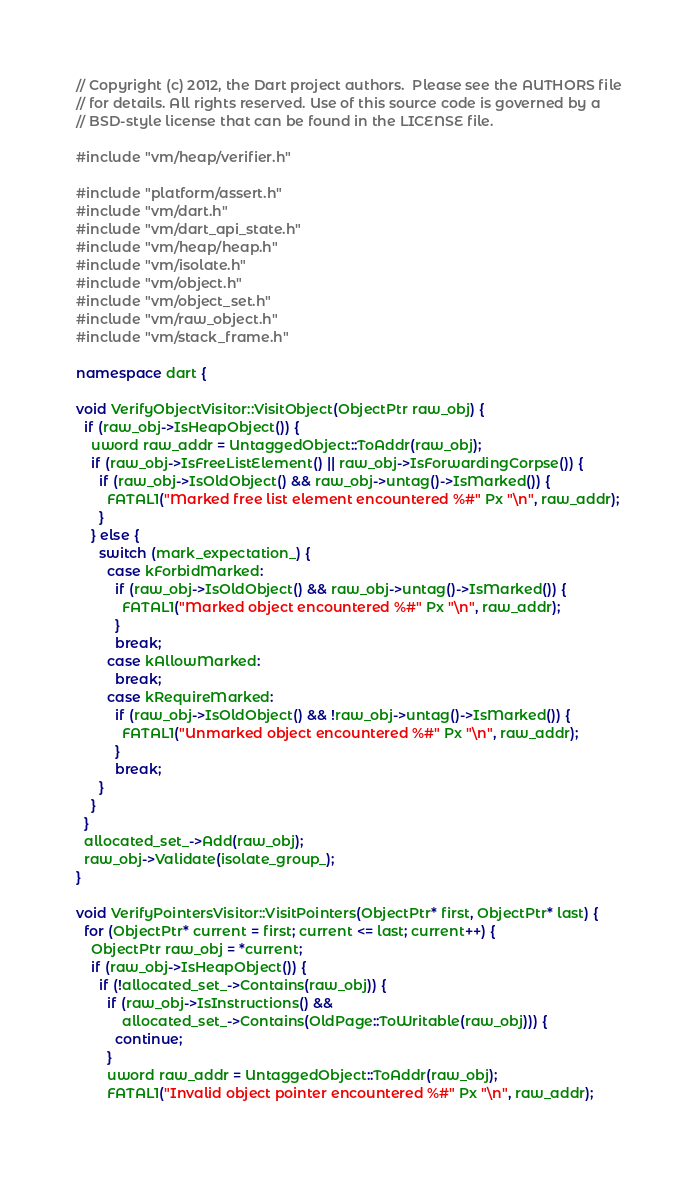Convert code to text. <code><loc_0><loc_0><loc_500><loc_500><_C++_>// Copyright (c) 2012, the Dart project authors.  Please see the AUTHORS file
// for details. All rights reserved. Use of this source code is governed by a
// BSD-style license that can be found in the LICENSE file.

#include "vm/heap/verifier.h"

#include "platform/assert.h"
#include "vm/dart.h"
#include "vm/dart_api_state.h"
#include "vm/heap/heap.h"
#include "vm/isolate.h"
#include "vm/object.h"
#include "vm/object_set.h"
#include "vm/raw_object.h"
#include "vm/stack_frame.h"

namespace dart {

void VerifyObjectVisitor::VisitObject(ObjectPtr raw_obj) {
  if (raw_obj->IsHeapObject()) {
    uword raw_addr = UntaggedObject::ToAddr(raw_obj);
    if (raw_obj->IsFreeListElement() || raw_obj->IsForwardingCorpse()) {
      if (raw_obj->IsOldObject() && raw_obj->untag()->IsMarked()) {
        FATAL1("Marked free list element encountered %#" Px "\n", raw_addr);
      }
    } else {
      switch (mark_expectation_) {
        case kForbidMarked:
          if (raw_obj->IsOldObject() && raw_obj->untag()->IsMarked()) {
            FATAL1("Marked object encountered %#" Px "\n", raw_addr);
          }
          break;
        case kAllowMarked:
          break;
        case kRequireMarked:
          if (raw_obj->IsOldObject() && !raw_obj->untag()->IsMarked()) {
            FATAL1("Unmarked object encountered %#" Px "\n", raw_addr);
          }
          break;
      }
    }
  }
  allocated_set_->Add(raw_obj);
  raw_obj->Validate(isolate_group_);
}

void VerifyPointersVisitor::VisitPointers(ObjectPtr* first, ObjectPtr* last) {
  for (ObjectPtr* current = first; current <= last; current++) {
    ObjectPtr raw_obj = *current;
    if (raw_obj->IsHeapObject()) {
      if (!allocated_set_->Contains(raw_obj)) {
        if (raw_obj->IsInstructions() &&
            allocated_set_->Contains(OldPage::ToWritable(raw_obj))) {
          continue;
        }
        uword raw_addr = UntaggedObject::ToAddr(raw_obj);
        FATAL1("Invalid object pointer encountered %#" Px "\n", raw_addr);</code> 